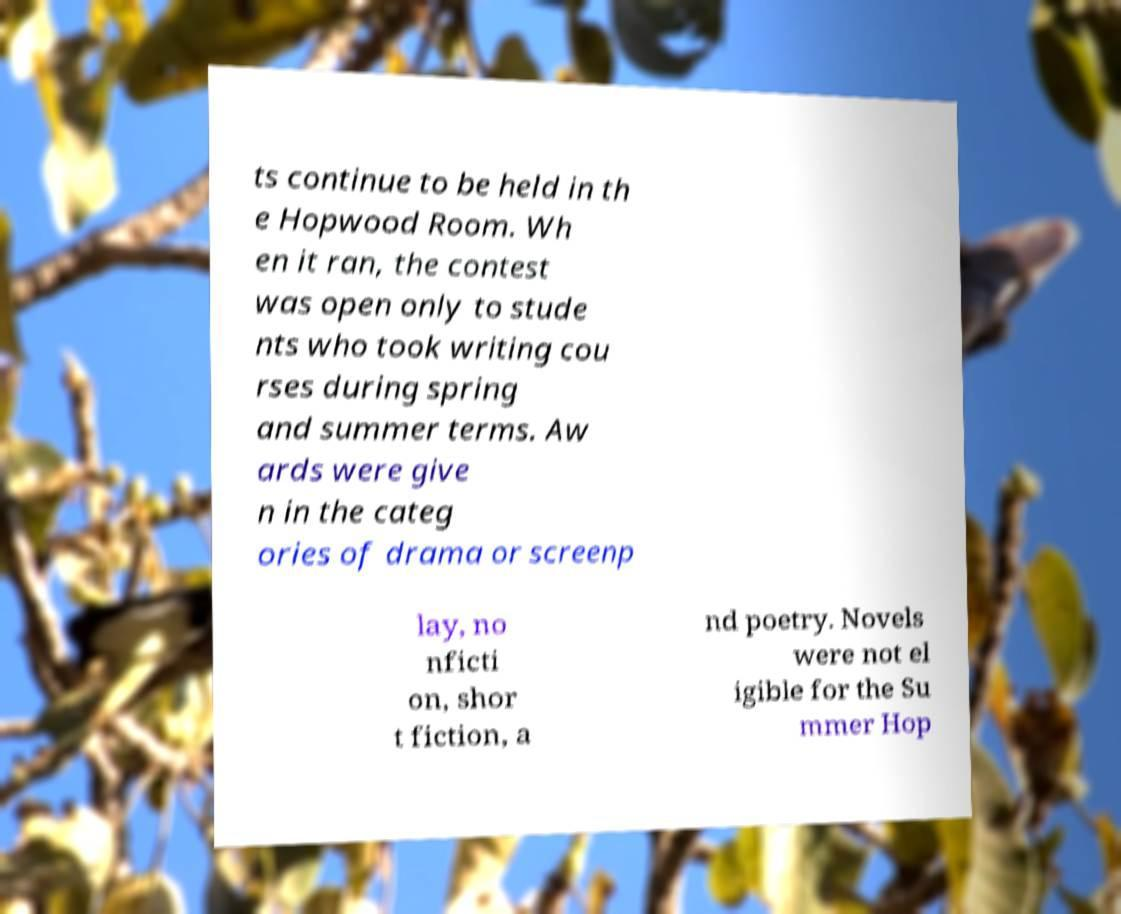Can you read and provide the text displayed in the image?This photo seems to have some interesting text. Can you extract and type it out for me? ts continue to be held in th e Hopwood Room. Wh en it ran, the contest was open only to stude nts who took writing cou rses during spring and summer terms. Aw ards were give n in the categ ories of drama or screenp lay, no nficti on, shor t fiction, a nd poetry. Novels were not el igible for the Su mmer Hop 